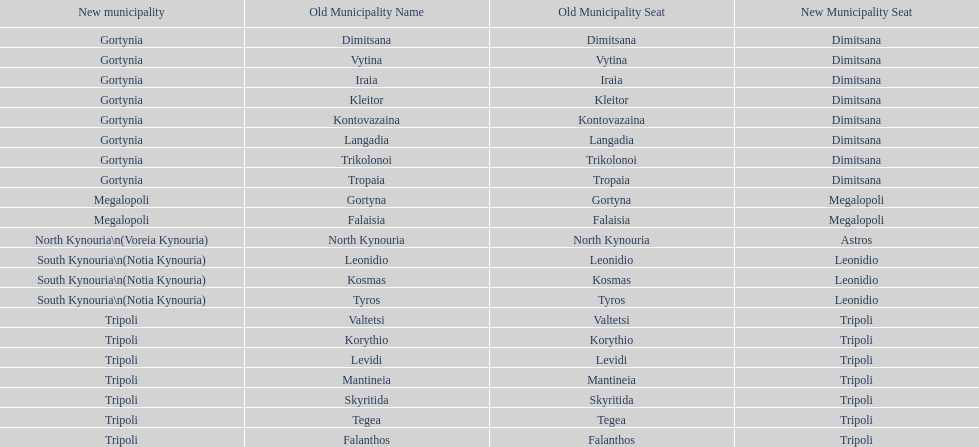How many old municipalities were in tripoli? 8. 